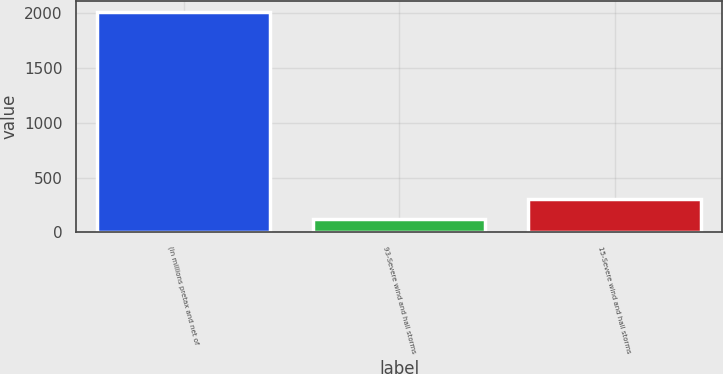<chart> <loc_0><loc_0><loc_500><loc_500><bar_chart><fcel>(in millions pretax and net of<fcel>93-Severe wind and hail storms<fcel>15-Severe wind and hail storms<nl><fcel>2014<fcel>119<fcel>308.5<nl></chart> 